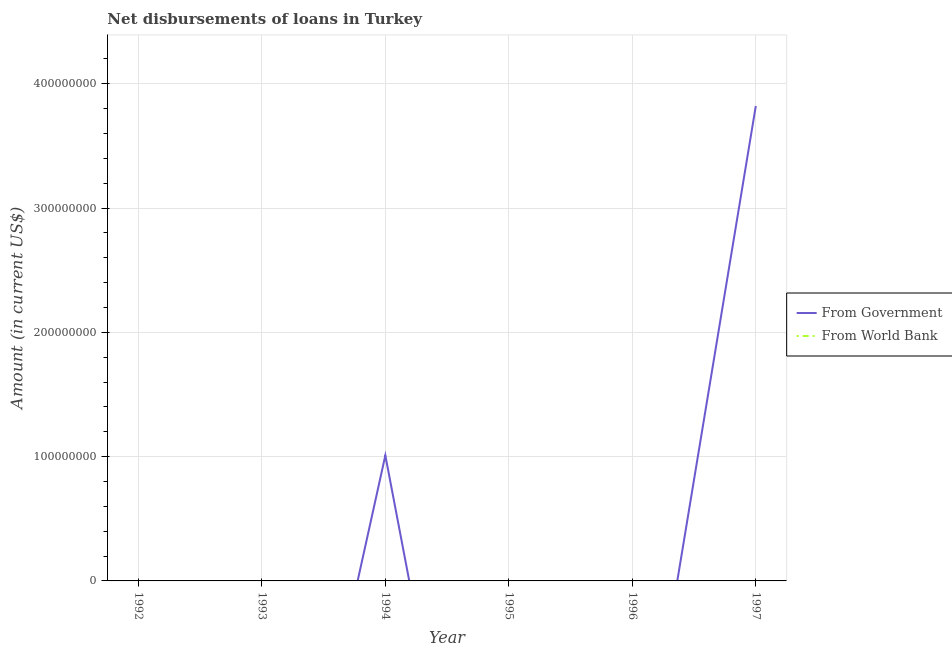How many different coloured lines are there?
Offer a very short reply. 1. Is the number of lines equal to the number of legend labels?
Provide a succinct answer. No. What is the net disbursements of loan from government in 1994?
Offer a very short reply. 1.01e+08. Across all years, what is the maximum net disbursements of loan from government?
Offer a terse response. 3.82e+08. Across all years, what is the minimum net disbursements of loan from government?
Your answer should be compact. 0. In which year was the net disbursements of loan from government maximum?
Make the answer very short. 1997. What is the difference between the net disbursements of loan from government in 1994 and the net disbursements of loan from world bank in 1993?
Ensure brevity in your answer.  1.01e+08. What is the average net disbursements of loan from government per year?
Your answer should be compact. 8.05e+07. What is the ratio of the net disbursements of loan from government in 1994 to that in 1997?
Offer a very short reply. 0.26. What is the difference between the highest and the lowest net disbursements of loan from government?
Your response must be concise. 3.82e+08. Is the net disbursements of loan from government strictly greater than the net disbursements of loan from world bank over the years?
Provide a short and direct response. No. Is the net disbursements of loan from world bank strictly less than the net disbursements of loan from government over the years?
Your response must be concise. No. How many years are there in the graph?
Make the answer very short. 6. Does the graph contain grids?
Your answer should be very brief. Yes. Where does the legend appear in the graph?
Provide a short and direct response. Center right. How many legend labels are there?
Offer a very short reply. 2. How are the legend labels stacked?
Ensure brevity in your answer.  Vertical. What is the title of the graph?
Make the answer very short. Net disbursements of loans in Turkey. Does "Under five" appear as one of the legend labels in the graph?
Keep it short and to the point. No. What is the Amount (in current US$) in From Government in 1992?
Your answer should be compact. 0. What is the Amount (in current US$) of From World Bank in 1993?
Your response must be concise. 0. What is the Amount (in current US$) in From Government in 1994?
Offer a terse response. 1.01e+08. What is the Amount (in current US$) of From Government in 1997?
Offer a very short reply. 3.82e+08. What is the Amount (in current US$) of From World Bank in 1997?
Your answer should be compact. 0. Across all years, what is the maximum Amount (in current US$) of From Government?
Offer a very short reply. 3.82e+08. Across all years, what is the minimum Amount (in current US$) in From Government?
Your answer should be compact. 0. What is the total Amount (in current US$) of From Government in the graph?
Keep it short and to the point. 4.83e+08. What is the total Amount (in current US$) in From World Bank in the graph?
Make the answer very short. 0. What is the difference between the Amount (in current US$) in From Government in 1994 and that in 1997?
Make the answer very short. -2.81e+08. What is the average Amount (in current US$) in From Government per year?
Keep it short and to the point. 8.05e+07. What is the ratio of the Amount (in current US$) of From Government in 1994 to that in 1997?
Give a very brief answer. 0.26. What is the difference between the highest and the lowest Amount (in current US$) in From Government?
Offer a very short reply. 3.82e+08. 